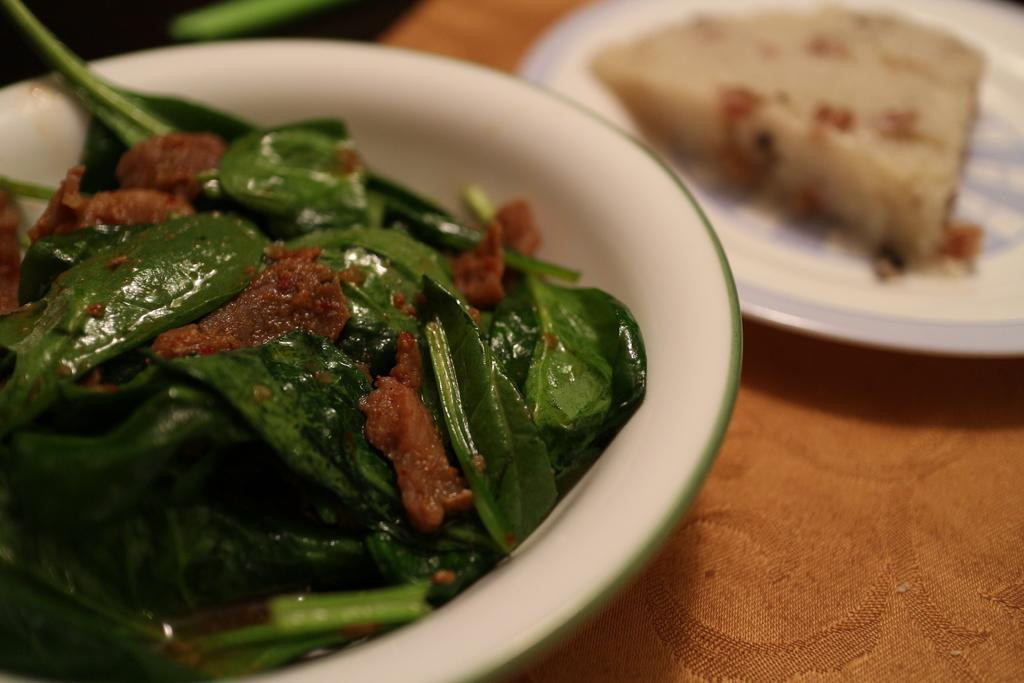What is on the plate that is visible in the image? There is food on a plate in the image. What type of vegetable can be seen in the image? There are spinach leaves in the image. What is in the bowl that is visible in the image? There is food in a bowl in the image. Where is the cloth located in the image? There is a cloth in the bottom right corner of the image. What type of respect can be seen in the image? There is no indication of respect in the image; it features food on a plate, spinach leaves, food in a bowl, and a cloth. Is there a flame visible in the image? No, there is no flame present in the image. 